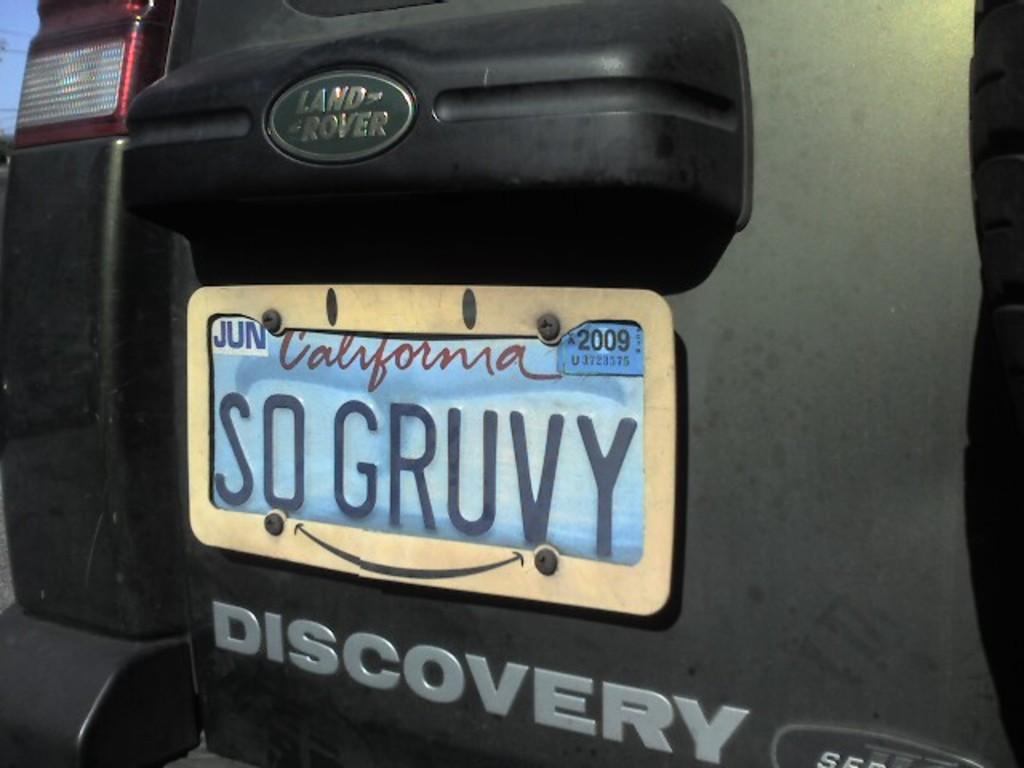<image>
Offer a succinct explanation of the picture presented. The back of a Discovery Land Rover with a California license plate that reads SO GRUVY. 